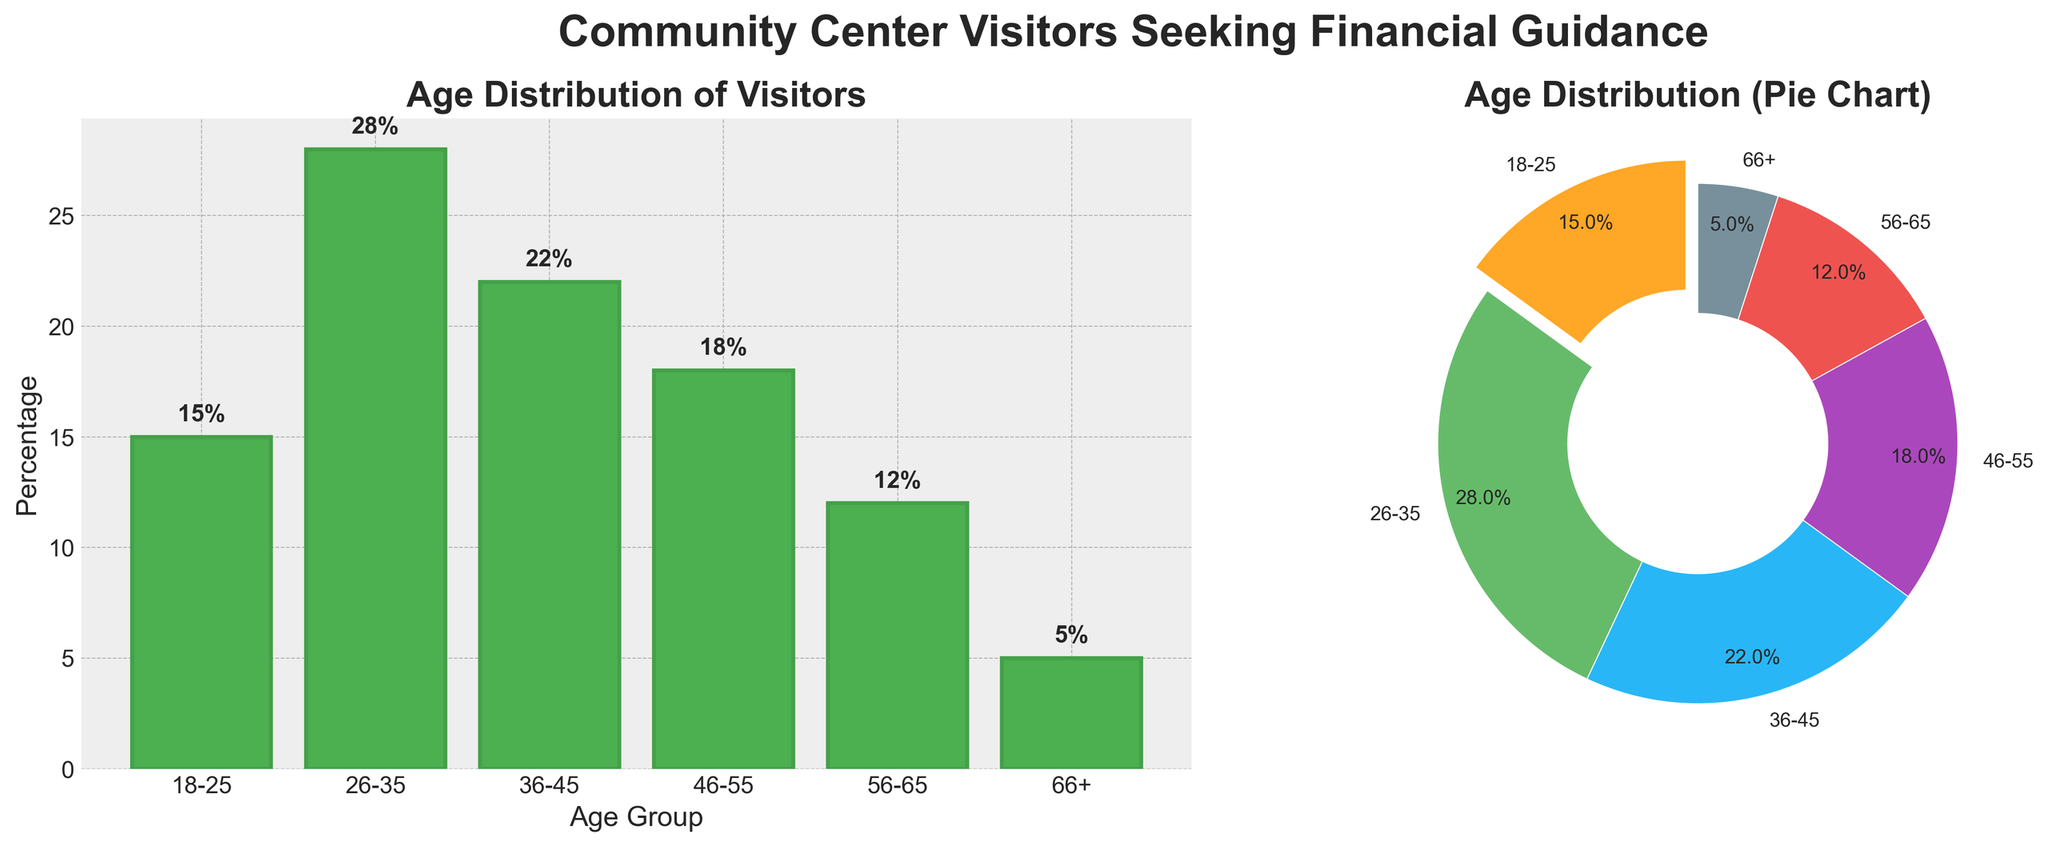What age group has the highest percentage of visitors? By looking at the heights of the bars in the bar plot or the sizes of the slices in the pie chart, the age group 26-35 has the highest percentage.
Answer: 26-35 How much higher is the percentage of visitors aged 26-35 compared to those aged 66+? The bar for 26-35 reaches 28%, and the bar for 66+ reaches 5%. Subtract 5 from 28 to find the difference.
Answer: 23% What percentage of visitors are 45 years old or younger? Add the percentages of the age groups 18-25, 26-35, and 36-45: 15 + 28 + 22 = 65%.
Answer: 65% Is the percentage of visitors aged 46-55 greater than that of visitors aged 56-65? The bar for 46-55 reaches 18%, whereas the bar for 56-65 reaches 12%. Since 18% is greater than 12%, the answer is yes.
Answer: Yes What is the total percentage of visitors aged 36-55? Add the percentages of the age groups 36-45 and 46-55: 22 + 18 = 40%.
Answer: 40% Among the age groups listed, which has the smallest proportion of visitors? By looking at the smallest bar in the bar plot and the smallest slice in the pie chart, the age group 66+ has the smallest proportion with 5%.
Answer: 66+ If we combined the visitors aged 18-25 and 56-65, would their combined percentage surpass any single age group? Add the percentages for 18-25 and 56-65: 15 + 12 = 27%. The highest individual percentage is for 26-35, which is 28%. Hence, 27% does not surpass 28%.
Answer: No Which age group's bar is represented in green in the bar chart? By visually identifying the color, the green bar in the bar chart represents the age group 26-35.
Answer: 26-35 What's the difference in percentage between the largest and smallest age groups? The largest age group is 26-35 with 28%, and the smallest is 66+ with 5%. Subtract 5 from 28 to get the difference.
Answer: 23% How does the percentage of visitors aged 36-45 compare to those aged 18-25? The percentage of visitors aged 36-45 is 22%, and for those aged 18-25, it is 15%. Since 22% is larger than 15%, the 36-45 group has a higher percentage.
Answer: 36-45 has a higher percentage 